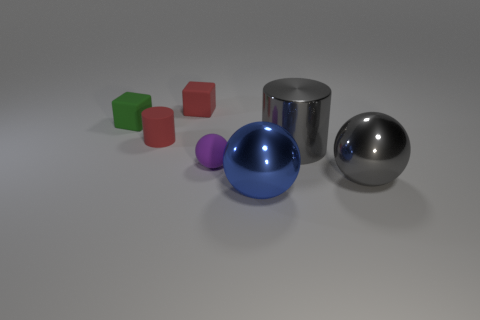What is the size of the rubber thing that is the same color as the rubber cylinder?
Your answer should be very brief. Small. Is the number of blue balls on the left side of the tiny rubber sphere the same as the number of large rubber balls?
Your response must be concise. Yes. How many objects are small balls or large things that are in front of the large shiny cylinder?
Give a very brief answer. 3. Is there a red cylinder that has the same material as the purple object?
Ensure brevity in your answer.  Yes. There is another small thing that is the same shape as the small green rubber object; what color is it?
Your answer should be compact. Red. Does the big cylinder have the same material as the large blue sphere in front of the gray ball?
Offer a terse response. Yes. The tiny object that is to the right of the tiny red object right of the tiny red cylinder is what shape?
Give a very brief answer. Sphere. There is a ball that is on the left side of the blue shiny thing; is it the same size as the blue thing?
Offer a terse response. No. What number of other things are there of the same shape as the small green object?
Give a very brief answer. 1. There is a block behind the small green matte thing; does it have the same color as the small rubber cylinder?
Provide a succinct answer. Yes. 